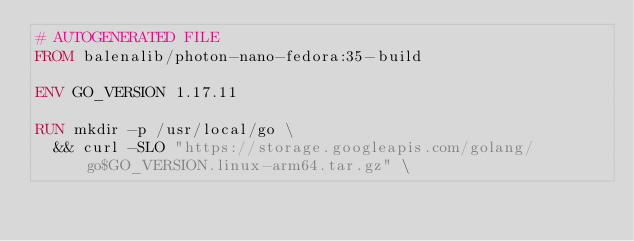<code> <loc_0><loc_0><loc_500><loc_500><_Dockerfile_># AUTOGENERATED FILE
FROM balenalib/photon-nano-fedora:35-build

ENV GO_VERSION 1.17.11

RUN mkdir -p /usr/local/go \
	&& curl -SLO "https://storage.googleapis.com/golang/go$GO_VERSION.linux-arm64.tar.gz" \</code> 